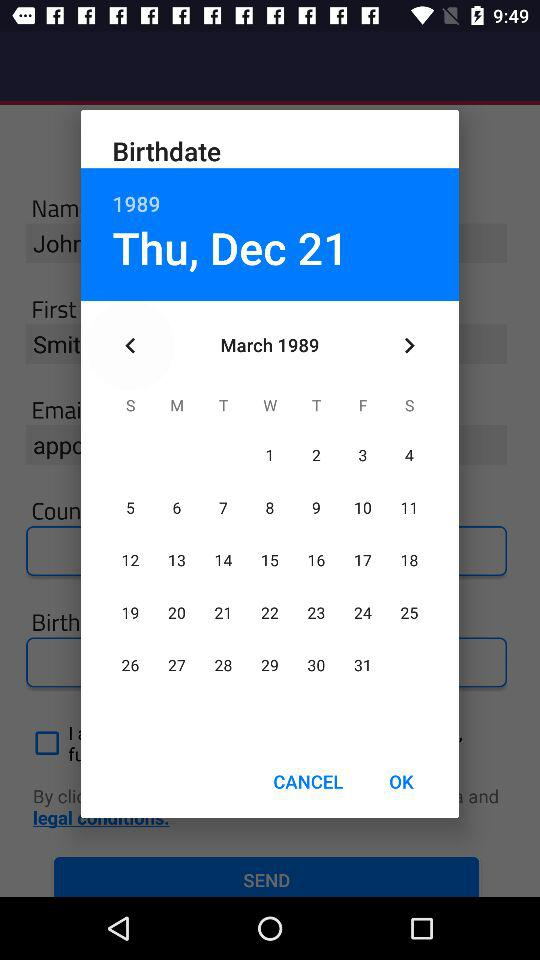Which day falls on December 21, 1989? The day is Thursday. 